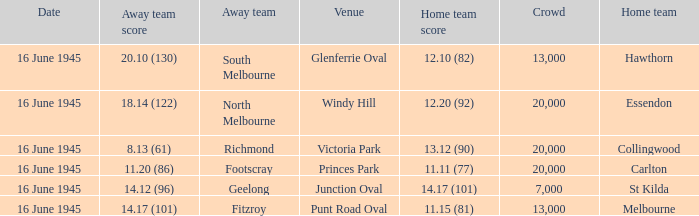What was the Home team score for the team that played South Melbourne? 12.10 (82). 